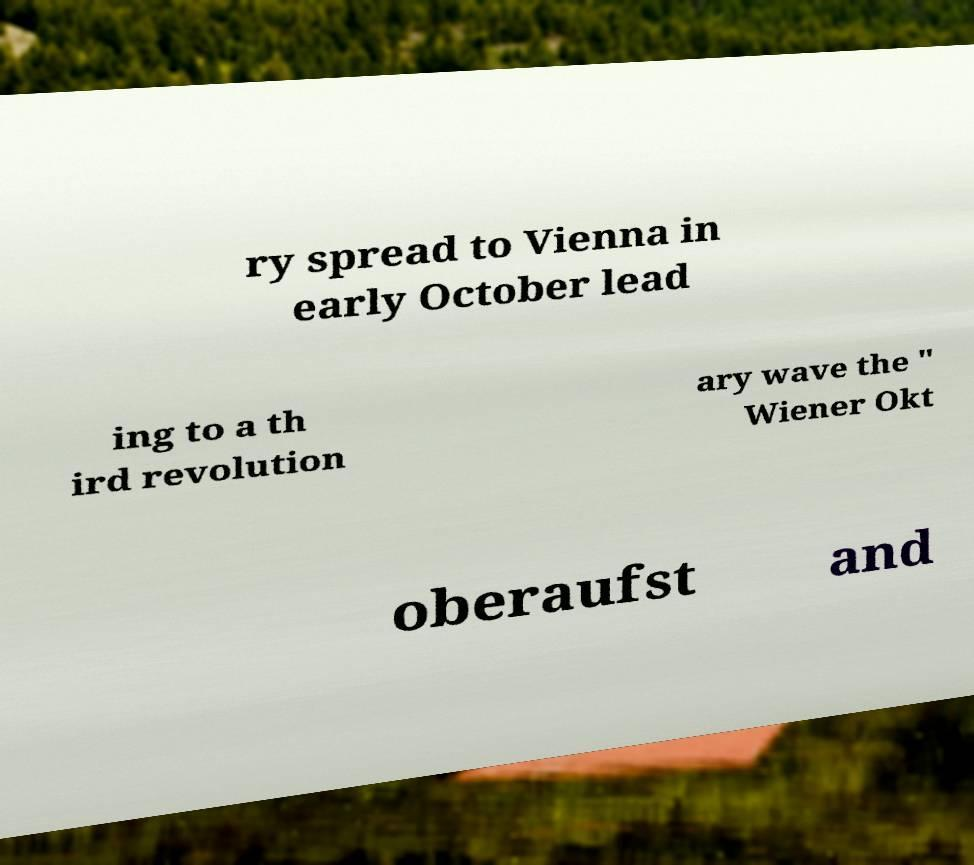I need the written content from this picture converted into text. Can you do that? ry spread to Vienna in early October lead ing to a th ird revolution ary wave the " Wiener Okt oberaufst and 